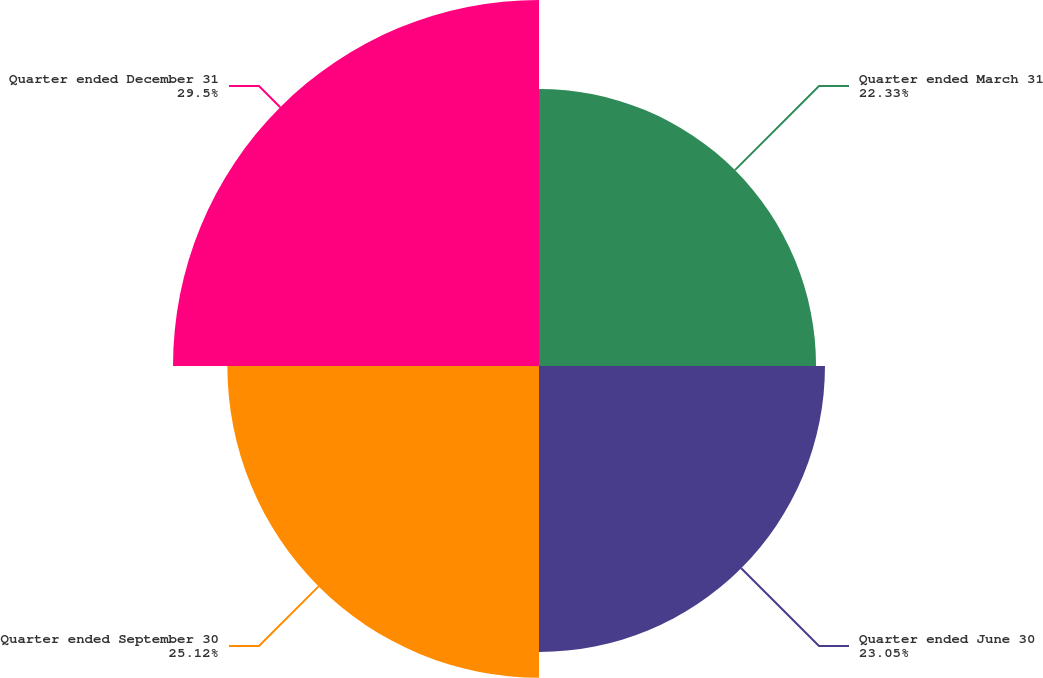Convert chart to OTSL. <chart><loc_0><loc_0><loc_500><loc_500><pie_chart><fcel>Quarter ended March 31<fcel>Quarter ended June 30<fcel>Quarter ended September 30<fcel>Quarter ended December 31<nl><fcel>22.33%<fcel>23.05%<fcel>25.12%<fcel>29.5%<nl></chart> 